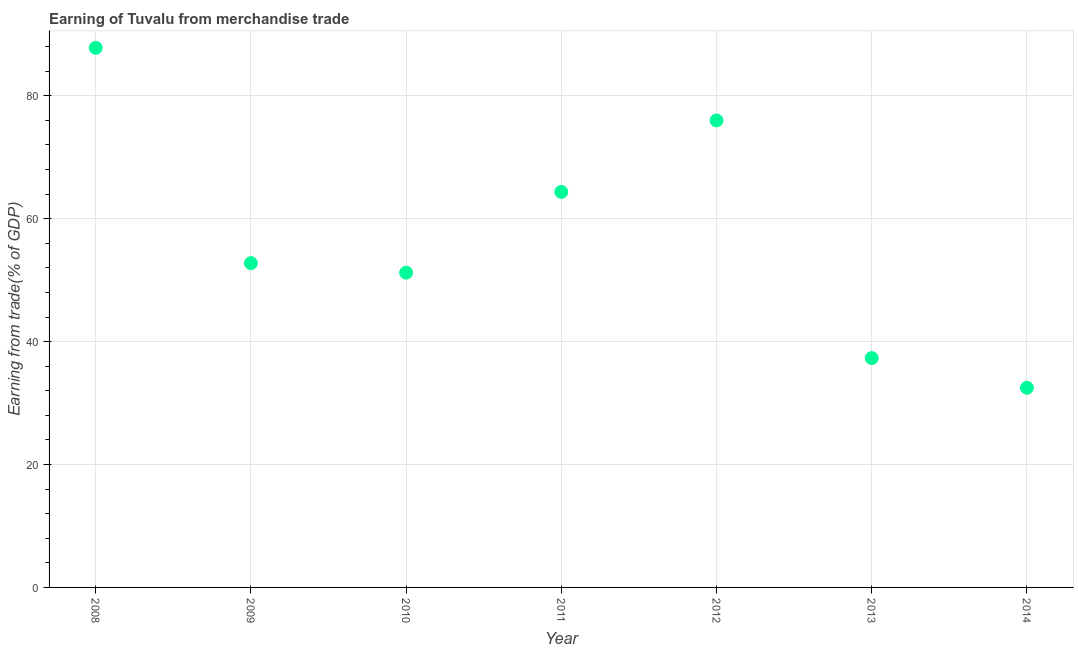What is the earning from merchandise trade in 2011?
Ensure brevity in your answer.  64.36. Across all years, what is the maximum earning from merchandise trade?
Offer a terse response. 87.8. Across all years, what is the minimum earning from merchandise trade?
Your answer should be very brief. 32.49. In which year was the earning from merchandise trade maximum?
Offer a terse response. 2008. What is the sum of the earning from merchandise trade?
Provide a succinct answer. 401.93. What is the difference between the earning from merchandise trade in 2010 and 2012?
Your response must be concise. -24.77. What is the average earning from merchandise trade per year?
Offer a terse response. 57.42. What is the median earning from merchandise trade?
Ensure brevity in your answer.  52.77. In how many years, is the earning from merchandise trade greater than 68 %?
Keep it short and to the point. 2. Do a majority of the years between 2009 and 2010 (inclusive) have earning from merchandise trade greater than 24 %?
Keep it short and to the point. Yes. What is the ratio of the earning from merchandise trade in 2011 to that in 2012?
Provide a succinct answer. 0.85. Is the earning from merchandise trade in 2009 less than that in 2011?
Give a very brief answer. Yes. Is the difference between the earning from merchandise trade in 2009 and 2011 greater than the difference between any two years?
Provide a succinct answer. No. What is the difference between the highest and the second highest earning from merchandise trade?
Give a very brief answer. 11.81. What is the difference between the highest and the lowest earning from merchandise trade?
Keep it short and to the point. 55.31. Does the earning from merchandise trade monotonically increase over the years?
Offer a terse response. No. How many dotlines are there?
Keep it short and to the point. 1. How many years are there in the graph?
Keep it short and to the point. 7. What is the difference between two consecutive major ticks on the Y-axis?
Your answer should be very brief. 20. Does the graph contain grids?
Your answer should be very brief. Yes. What is the title of the graph?
Your answer should be compact. Earning of Tuvalu from merchandise trade. What is the label or title of the Y-axis?
Provide a succinct answer. Earning from trade(% of GDP). What is the Earning from trade(% of GDP) in 2008?
Your answer should be very brief. 87.8. What is the Earning from trade(% of GDP) in 2009?
Your answer should be compact. 52.77. What is the Earning from trade(% of GDP) in 2010?
Offer a very short reply. 51.22. What is the Earning from trade(% of GDP) in 2011?
Provide a short and direct response. 64.36. What is the Earning from trade(% of GDP) in 2012?
Your response must be concise. 75.99. What is the Earning from trade(% of GDP) in 2013?
Give a very brief answer. 37.32. What is the Earning from trade(% of GDP) in 2014?
Make the answer very short. 32.49. What is the difference between the Earning from trade(% of GDP) in 2008 and 2009?
Ensure brevity in your answer.  35.04. What is the difference between the Earning from trade(% of GDP) in 2008 and 2010?
Ensure brevity in your answer.  36.58. What is the difference between the Earning from trade(% of GDP) in 2008 and 2011?
Provide a short and direct response. 23.44. What is the difference between the Earning from trade(% of GDP) in 2008 and 2012?
Ensure brevity in your answer.  11.81. What is the difference between the Earning from trade(% of GDP) in 2008 and 2013?
Your answer should be very brief. 50.49. What is the difference between the Earning from trade(% of GDP) in 2008 and 2014?
Offer a very short reply. 55.31. What is the difference between the Earning from trade(% of GDP) in 2009 and 2010?
Make the answer very short. 1.55. What is the difference between the Earning from trade(% of GDP) in 2009 and 2011?
Give a very brief answer. -11.59. What is the difference between the Earning from trade(% of GDP) in 2009 and 2012?
Keep it short and to the point. -23.22. What is the difference between the Earning from trade(% of GDP) in 2009 and 2013?
Ensure brevity in your answer.  15.45. What is the difference between the Earning from trade(% of GDP) in 2009 and 2014?
Keep it short and to the point. 20.28. What is the difference between the Earning from trade(% of GDP) in 2010 and 2011?
Provide a succinct answer. -13.14. What is the difference between the Earning from trade(% of GDP) in 2010 and 2012?
Make the answer very short. -24.77. What is the difference between the Earning from trade(% of GDP) in 2010 and 2013?
Your answer should be compact. 13.9. What is the difference between the Earning from trade(% of GDP) in 2010 and 2014?
Provide a succinct answer. 18.73. What is the difference between the Earning from trade(% of GDP) in 2011 and 2012?
Provide a short and direct response. -11.63. What is the difference between the Earning from trade(% of GDP) in 2011 and 2013?
Provide a succinct answer. 27.04. What is the difference between the Earning from trade(% of GDP) in 2011 and 2014?
Give a very brief answer. 31.87. What is the difference between the Earning from trade(% of GDP) in 2012 and 2013?
Make the answer very short. 38.67. What is the difference between the Earning from trade(% of GDP) in 2012 and 2014?
Your answer should be compact. 43.5. What is the difference between the Earning from trade(% of GDP) in 2013 and 2014?
Your response must be concise. 4.83. What is the ratio of the Earning from trade(% of GDP) in 2008 to that in 2009?
Ensure brevity in your answer.  1.66. What is the ratio of the Earning from trade(% of GDP) in 2008 to that in 2010?
Your response must be concise. 1.71. What is the ratio of the Earning from trade(% of GDP) in 2008 to that in 2011?
Offer a terse response. 1.36. What is the ratio of the Earning from trade(% of GDP) in 2008 to that in 2012?
Ensure brevity in your answer.  1.16. What is the ratio of the Earning from trade(% of GDP) in 2008 to that in 2013?
Offer a very short reply. 2.35. What is the ratio of the Earning from trade(% of GDP) in 2008 to that in 2014?
Give a very brief answer. 2.7. What is the ratio of the Earning from trade(% of GDP) in 2009 to that in 2011?
Provide a succinct answer. 0.82. What is the ratio of the Earning from trade(% of GDP) in 2009 to that in 2012?
Provide a short and direct response. 0.69. What is the ratio of the Earning from trade(% of GDP) in 2009 to that in 2013?
Offer a very short reply. 1.41. What is the ratio of the Earning from trade(% of GDP) in 2009 to that in 2014?
Ensure brevity in your answer.  1.62. What is the ratio of the Earning from trade(% of GDP) in 2010 to that in 2011?
Keep it short and to the point. 0.8. What is the ratio of the Earning from trade(% of GDP) in 2010 to that in 2012?
Make the answer very short. 0.67. What is the ratio of the Earning from trade(% of GDP) in 2010 to that in 2013?
Provide a succinct answer. 1.37. What is the ratio of the Earning from trade(% of GDP) in 2010 to that in 2014?
Offer a terse response. 1.58. What is the ratio of the Earning from trade(% of GDP) in 2011 to that in 2012?
Make the answer very short. 0.85. What is the ratio of the Earning from trade(% of GDP) in 2011 to that in 2013?
Your answer should be compact. 1.73. What is the ratio of the Earning from trade(% of GDP) in 2011 to that in 2014?
Ensure brevity in your answer.  1.98. What is the ratio of the Earning from trade(% of GDP) in 2012 to that in 2013?
Offer a terse response. 2.04. What is the ratio of the Earning from trade(% of GDP) in 2012 to that in 2014?
Provide a succinct answer. 2.34. What is the ratio of the Earning from trade(% of GDP) in 2013 to that in 2014?
Give a very brief answer. 1.15. 